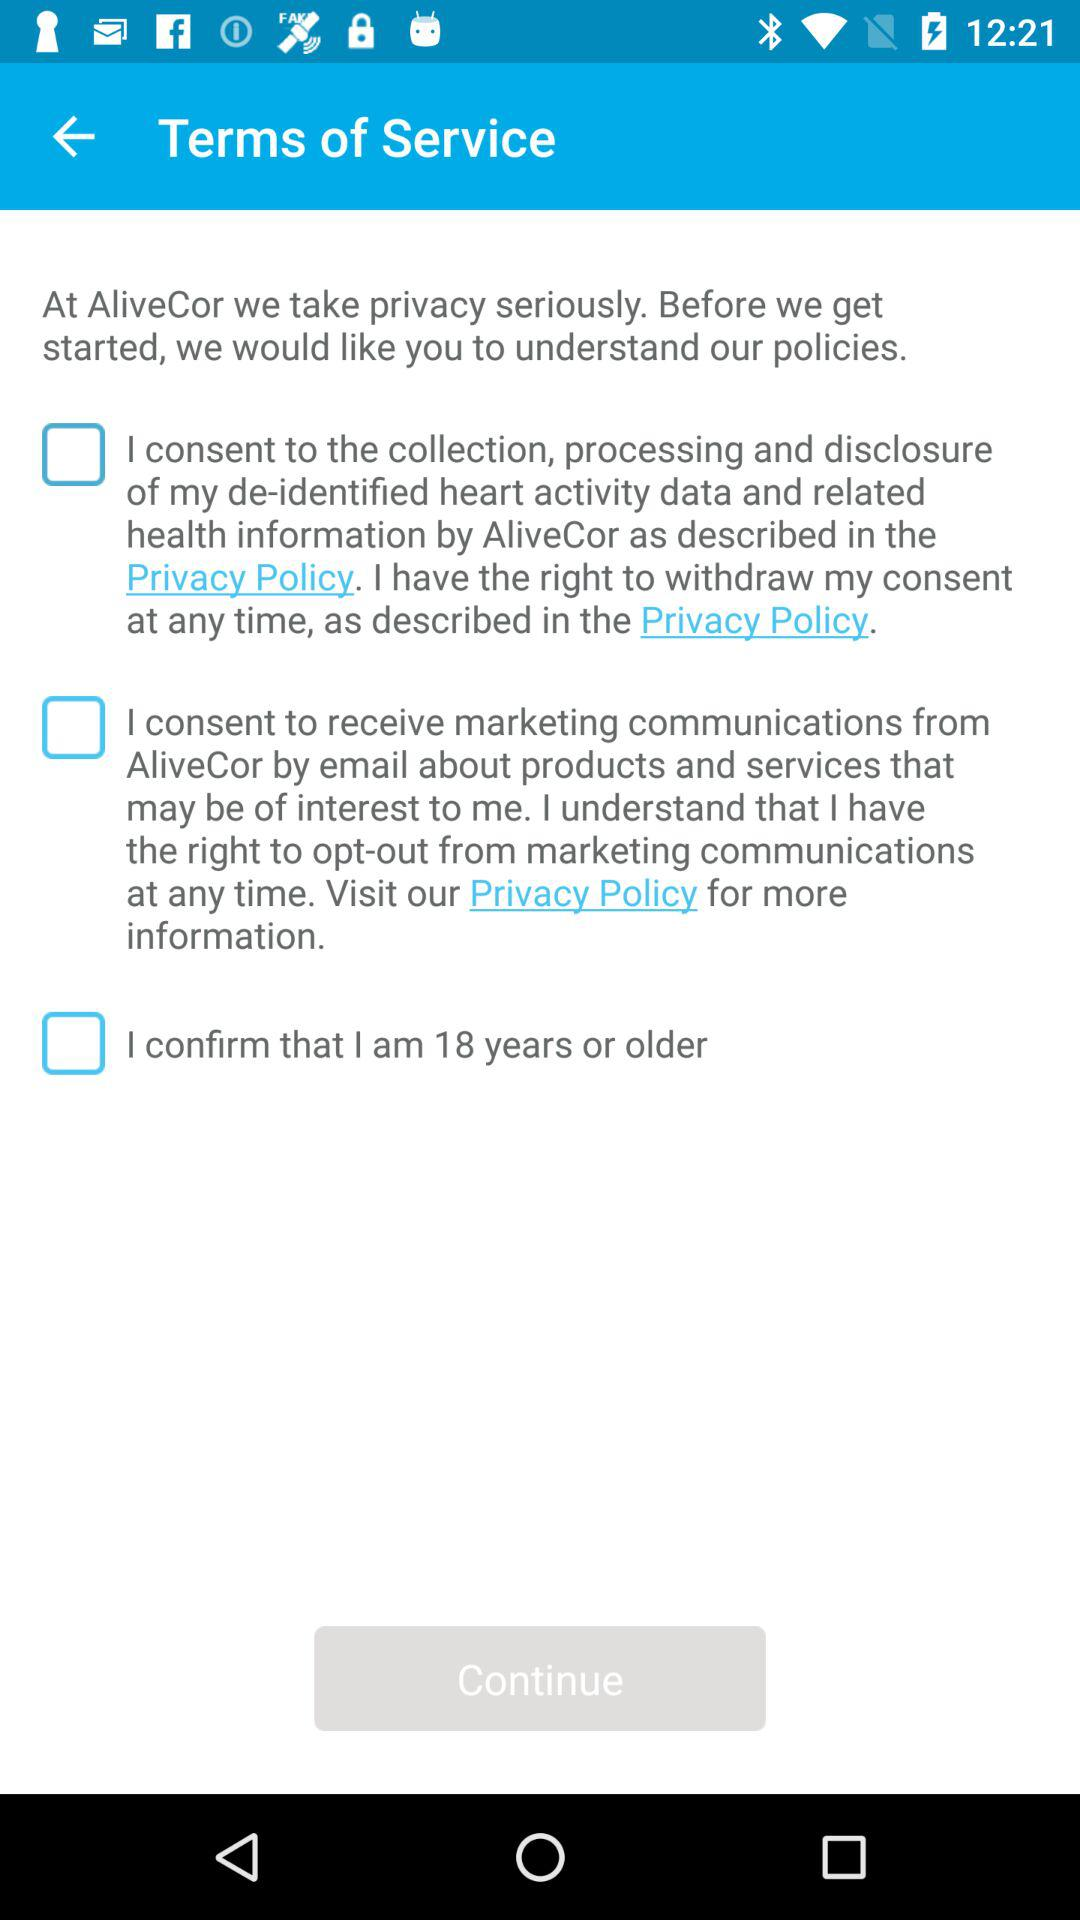How many check boxes are there on this screen?
Answer the question using a single word or phrase. 3 